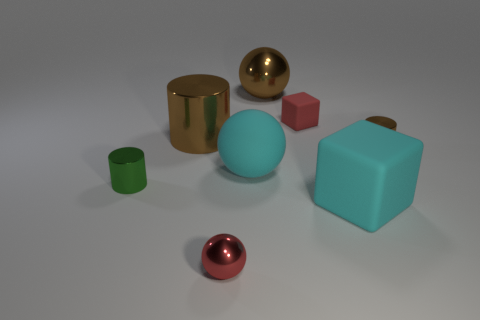There is a tiny red object that is in front of the big cylinder; does it have the same shape as the rubber object that is to the left of the small red matte cube?
Offer a very short reply. Yes. Is there a big cyan object made of the same material as the large brown cylinder?
Make the answer very short. No. What is the color of the tiny object left of the small red object in front of the big cyan block in front of the big brown metallic cylinder?
Provide a succinct answer. Green. Are the block that is in front of the small brown thing and the big sphere behind the small red rubber object made of the same material?
Your response must be concise. No. The matte thing that is in front of the tiny green metallic cylinder has what shape?
Ensure brevity in your answer.  Cube. What number of objects are cyan matte balls or tiny red rubber blocks to the right of the big cyan rubber sphere?
Ensure brevity in your answer.  2. Are the cyan sphere and the small red block made of the same material?
Your answer should be very brief. Yes. Is the number of small red things that are in front of the cyan sphere the same as the number of large cubes that are in front of the big cyan matte block?
Give a very brief answer. No. There is a tiny green metal object; what number of balls are behind it?
Provide a succinct answer. 2. What number of objects are either big brown spheres or small cylinders?
Offer a terse response. 3. 